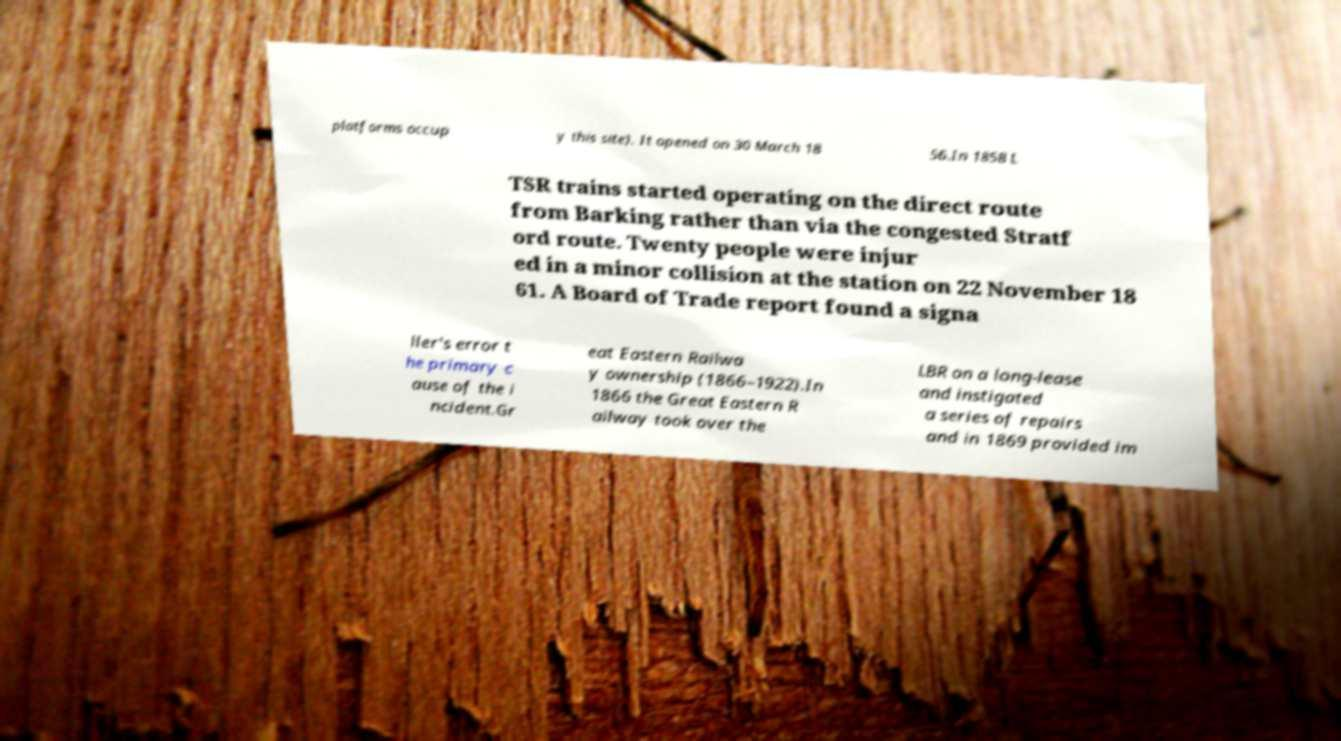I need the written content from this picture converted into text. Can you do that? platforms occup y this site). It opened on 30 March 18 56.In 1858 L TSR trains started operating on the direct route from Barking rather than via the congested Stratf ord route. Twenty people were injur ed in a minor collision at the station on 22 November 18 61. A Board of Trade report found a signa ller's error t he primary c ause of the i ncident.Gr eat Eastern Railwa y ownership (1866–1922).In 1866 the Great Eastern R ailway took over the LBR on a long-lease and instigated a series of repairs and in 1869 provided im 